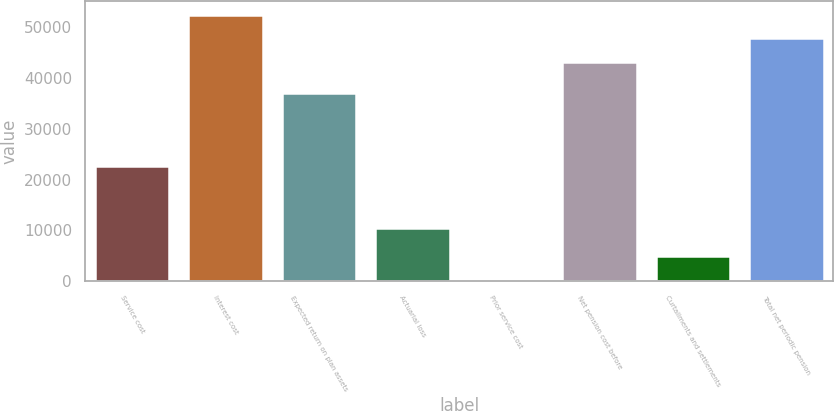<chart> <loc_0><loc_0><loc_500><loc_500><bar_chart><fcel>Service cost<fcel>Interest cost<fcel>Expected return on plan assets<fcel>Actuarial loss<fcel>Prior service cost<fcel>Net pension cost before<fcel>Curtailments and settlements<fcel>Total net periodic pension<nl><fcel>22722<fcel>52357.2<fcel>36988<fcel>10488<fcel>293<fcel>43099<fcel>4922.1<fcel>47728.1<nl></chart> 